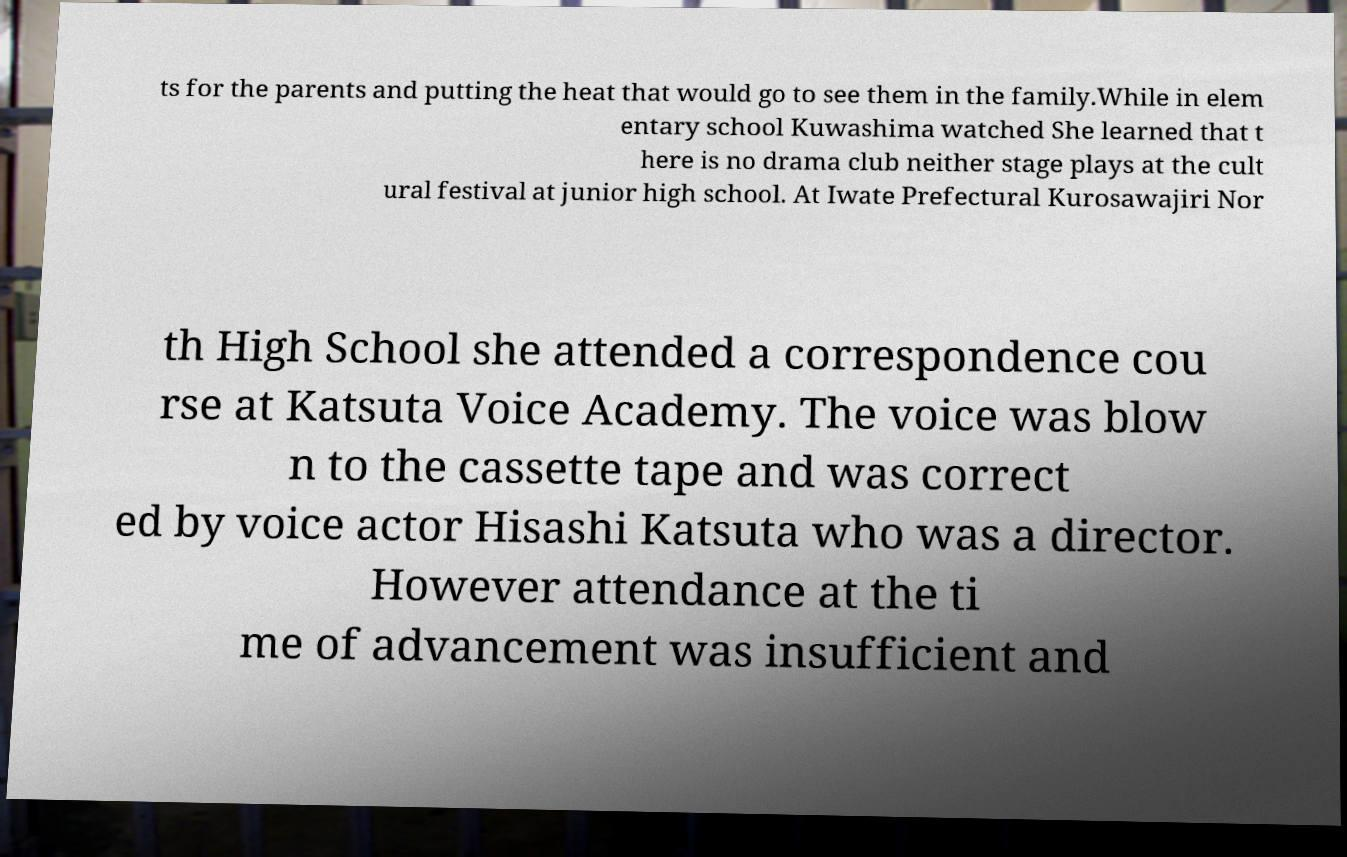Please read and relay the text visible in this image. What does it say? ts for the parents and putting the heat that would go to see them in the family.While in elem entary school Kuwashima watched She learned that t here is no drama club neither stage plays at the cult ural festival at junior high school. At Iwate Prefectural Kurosawajiri Nor th High School she attended a correspondence cou rse at Katsuta Voice Academy. The voice was blow n to the cassette tape and was correct ed by voice actor Hisashi Katsuta who was a director. However attendance at the ti me of advancement was insufficient and 